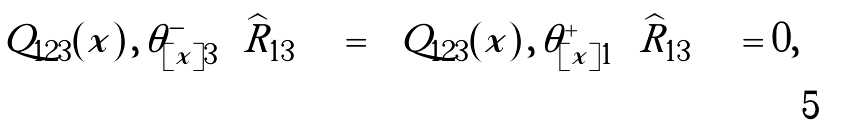<formula> <loc_0><loc_0><loc_500><loc_500>\left [ \, Q _ { 1 2 3 } ( x ) \, , \, \theta ^ { - } _ { [ x ] 3 } \left ( \widehat { R } _ { 1 3 } \right ) \, \right ] = \left [ \, Q _ { 1 2 3 } ( x ) \, , \, \theta ^ { + } _ { [ x ] 1 } \left ( \widehat { R } _ { 1 3 } \right ) \, \right ] = 0 ,</formula> 